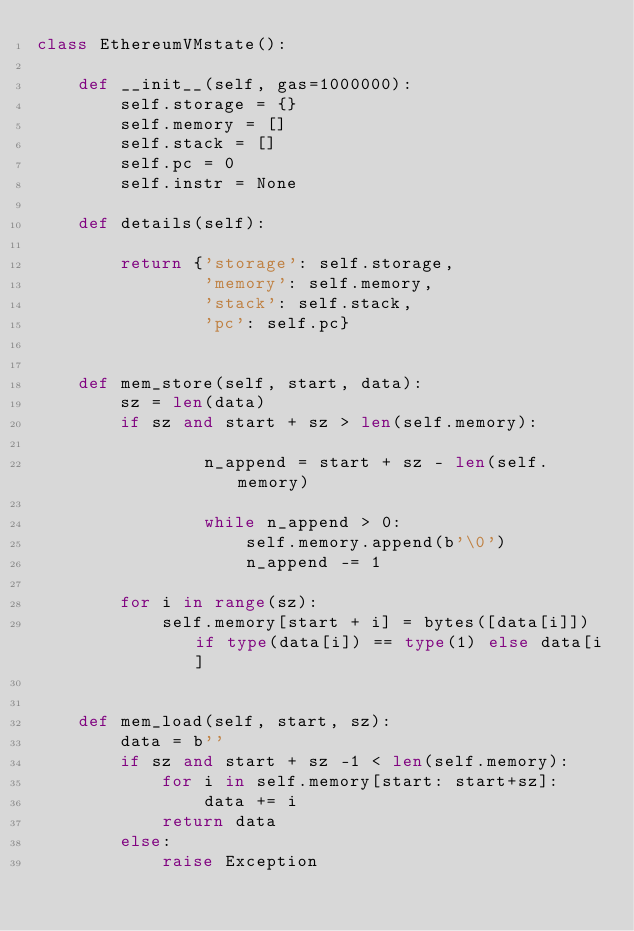<code> <loc_0><loc_0><loc_500><loc_500><_Python_>class EthereumVMstate():

    def __init__(self, gas=1000000):
        self.storage = {}
        self.memory = []
        self.stack = []
        self.pc = 0
        self.instr = None

    def details(self):

        return {'storage': self.storage,
                'memory': self.memory,
                'stack': self.stack,
                'pc': self.pc}


    def mem_store(self, start, data):
        sz = len(data)
        if sz and start + sz > len(self.memory):

                n_append = start + sz - len(self.memory)

                while n_append > 0:
                    self.memory.append(b'\0')
                    n_append -= 1

        for i in range(sz):
            self.memory[start + i] = bytes([data[i]]) if type(data[i]) == type(1) else data[i]


    def mem_load(self, start, sz):
        data = b''
        if sz and start + sz -1 < len(self.memory):
            for i in self.memory[start: start+sz]:
                data += i
            return data
        else:
            raise Exception

</code> 